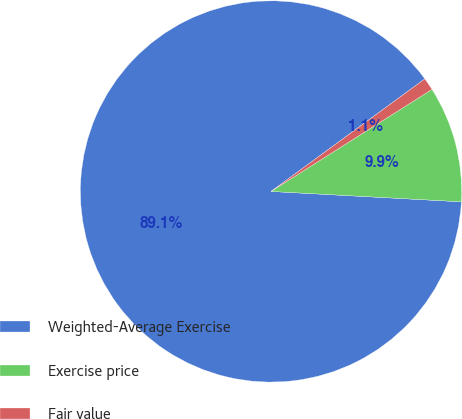<chart> <loc_0><loc_0><loc_500><loc_500><pie_chart><fcel>Weighted-Average Exercise<fcel>Exercise price<fcel>Fair value<nl><fcel>89.08%<fcel>9.86%<fcel>1.06%<nl></chart> 